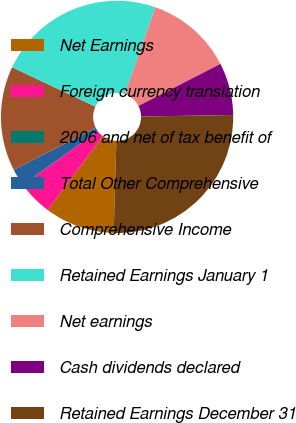Convert chart. <chart><loc_0><loc_0><loc_500><loc_500><pie_chart><fcel>Net Earnings<fcel>Foreign currency translation<fcel>2006 and net of tax benefit of<fcel>Total Other Comprehensive<fcel>Comprehensive Income<fcel>Retained Earnings January 1<fcel>Net earnings<fcel>Cash dividends declared<fcel>Retained Earnings December 31<nl><fcel>9.71%<fcel>4.86%<fcel>0.01%<fcel>2.43%<fcel>14.56%<fcel>23.3%<fcel>12.13%<fcel>7.28%<fcel>25.72%<nl></chart> 